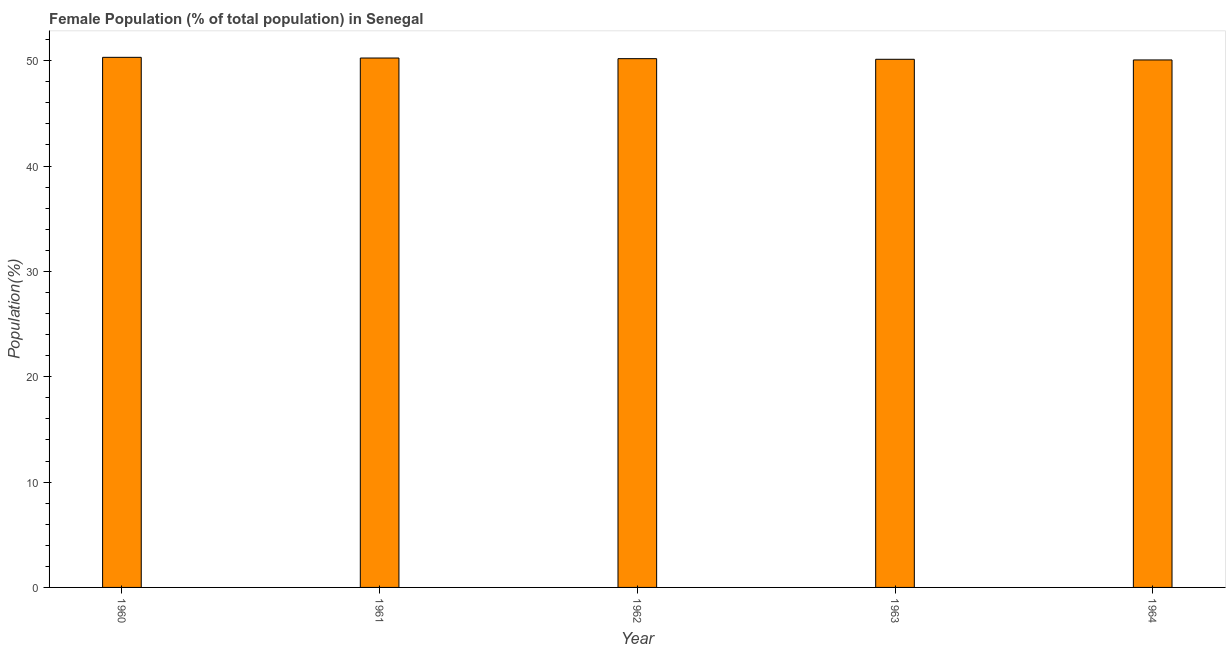Does the graph contain any zero values?
Make the answer very short. No. What is the title of the graph?
Ensure brevity in your answer.  Female Population (% of total population) in Senegal. What is the label or title of the Y-axis?
Offer a terse response. Population(%). What is the female population in 1964?
Make the answer very short. 50.07. Across all years, what is the maximum female population?
Offer a terse response. 50.32. Across all years, what is the minimum female population?
Your answer should be very brief. 50.07. In which year was the female population maximum?
Make the answer very short. 1960. In which year was the female population minimum?
Keep it short and to the point. 1964. What is the sum of the female population?
Offer a very short reply. 250.98. What is the average female population per year?
Provide a short and direct response. 50.2. What is the median female population?
Make the answer very short. 50.2. In how many years, is the female population greater than 48 %?
Your answer should be very brief. 5. Do a majority of the years between 1961 and 1962 (inclusive) have female population greater than 36 %?
Ensure brevity in your answer.  Yes. What is the ratio of the female population in 1962 to that in 1964?
Your answer should be compact. 1. Is the female population in 1961 less than that in 1962?
Keep it short and to the point. No. Is the difference between the female population in 1963 and 1964 greater than the difference between any two years?
Your answer should be compact. No. What is the difference between the highest and the second highest female population?
Ensure brevity in your answer.  0.07. Are all the bars in the graph horizontal?
Make the answer very short. No. What is the difference between two consecutive major ticks on the Y-axis?
Your answer should be very brief. 10. What is the Population(%) in 1960?
Your response must be concise. 50.32. What is the Population(%) of 1961?
Your answer should be compact. 50.26. What is the Population(%) of 1962?
Offer a very short reply. 50.2. What is the Population(%) in 1963?
Provide a short and direct response. 50.14. What is the Population(%) in 1964?
Offer a terse response. 50.07. What is the difference between the Population(%) in 1960 and 1961?
Your answer should be compact. 0.07. What is the difference between the Population(%) in 1960 and 1962?
Offer a very short reply. 0.13. What is the difference between the Population(%) in 1960 and 1963?
Your answer should be very brief. 0.19. What is the difference between the Population(%) in 1960 and 1964?
Provide a succinct answer. 0.25. What is the difference between the Population(%) in 1961 and 1962?
Your response must be concise. 0.06. What is the difference between the Population(%) in 1961 and 1963?
Keep it short and to the point. 0.12. What is the difference between the Population(%) in 1961 and 1964?
Ensure brevity in your answer.  0.18. What is the difference between the Population(%) in 1962 and 1963?
Provide a short and direct response. 0.06. What is the difference between the Population(%) in 1962 and 1964?
Give a very brief answer. 0.12. What is the difference between the Population(%) in 1963 and 1964?
Your response must be concise. 0.06. What is the ratio of the Population(%) in 1960 to that in 1964?
Ensure brevity in your answer.  1. What is the ratio of the Population(%) in 1961 to that in 1962?
Keep it short and to the point. 1. What is the ratio of the Population(%) in 1961 to that in 1963?
Your response must be concise. 1. What is the ratio of the Population(%) in 1961 to that in 1964?
Make the answer very short. 1. 